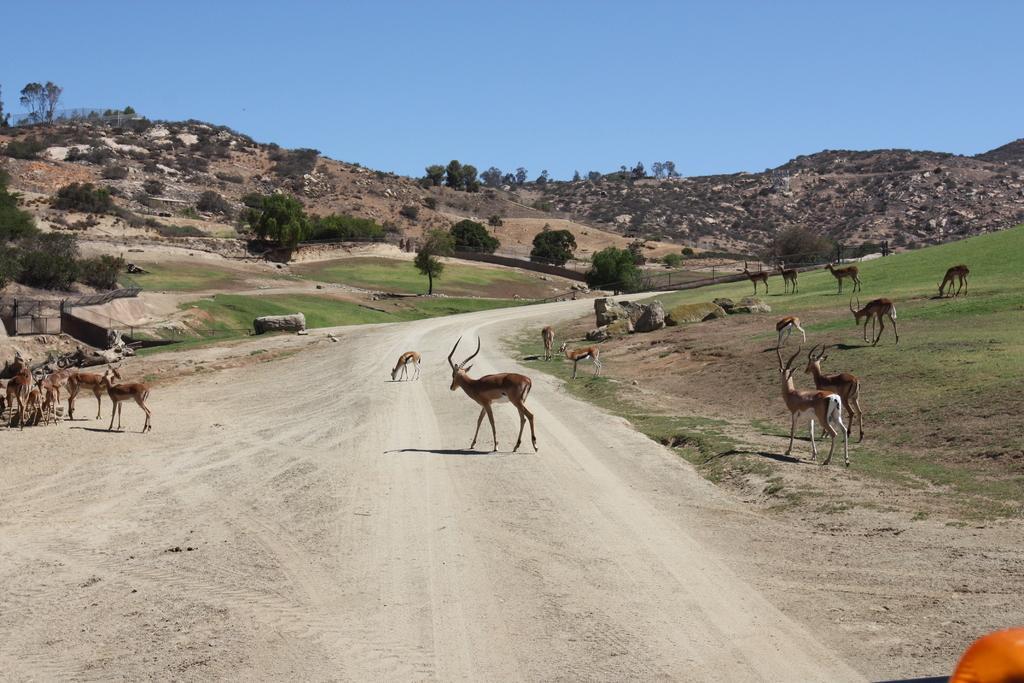Please provide a concise description of this image. In this image we can see a few deer on the road and a few deer on the grass. Here we can see the rocks, we can see trees, hills and the blue color sky in the background. 